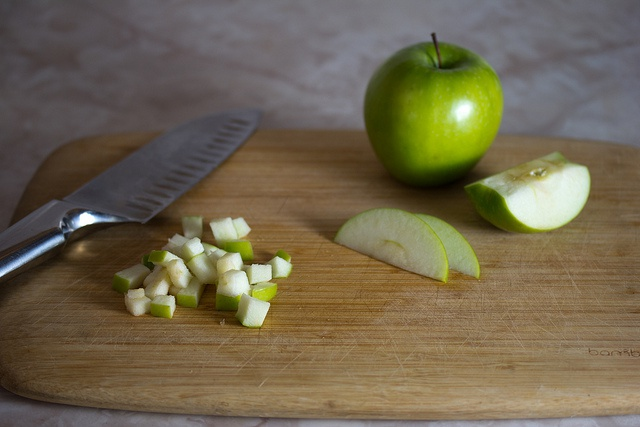Describe the objects in this image and their specific colors. I can see apple in black, olive, beige, and darkgray tones, apple in black, darkgreen, and olive tones, and knife in black and gray tones in this image. 